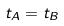<formula> <loc_0><loc_0><loc_500><loc_500>t _ { A } = t _ { B }</formula> 